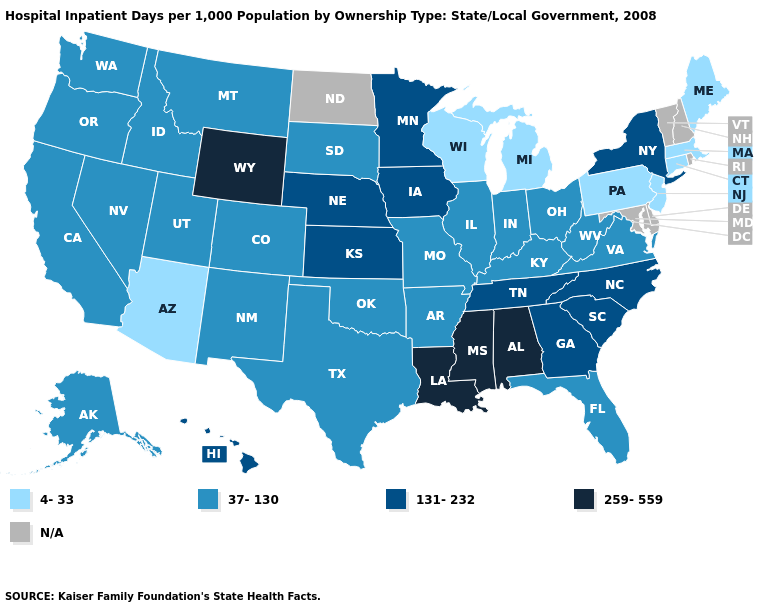Name the states that have a value in the range N/A?
Short answer required. Delaware, Maryland, New Hampshire, North Dakota, Rhode Island, Vermont. How many symbols are there in the legend?
Be succinct. 5. How many symbols are there in the legend?
Concise answer only. 5. What is the value of Missouri?
Quick response, please. 37-130. What is the value of New York?
Quick response, please. 131-232. What is the value of Ohio?
Keep it brief. 37-130. What is the value of Washington?
Concise answer only. 37-130. Name the states that have a value in the range 4-33?
Keep it brief. Arizona, Connecticut, Maine, Massachusetts, Michigan, New Jersey, Pennsylvania, Wisconsin. What is the value of Michigan?
Short answer required. 4-33. What is the value of Nevada?
Short answer required. 37-130. Name the states that have a value in the range 37-130?
Give a very brief answer. Alaska, Arkansas, California, Colorado, Florida, Idaho, Illinois, Indiana, Kentucky, Missouri, Montana, Nevada, New Mexico, Ohio, Oklahoma, Oregon, South Dakota, Texas, Utah, Virginia, Washington, West Virginia. Among the states that border North Dakota , does Montana have the highest value?
Be succinct. No. Does Wyoming have the highest value in the USA?
Keep it brief. Yes. Does the first symbol in the legend represent the smallest category?
Short answer required. Yes. What is the highest value in states that border Oklahoma?
Be succinct. 131-232. 